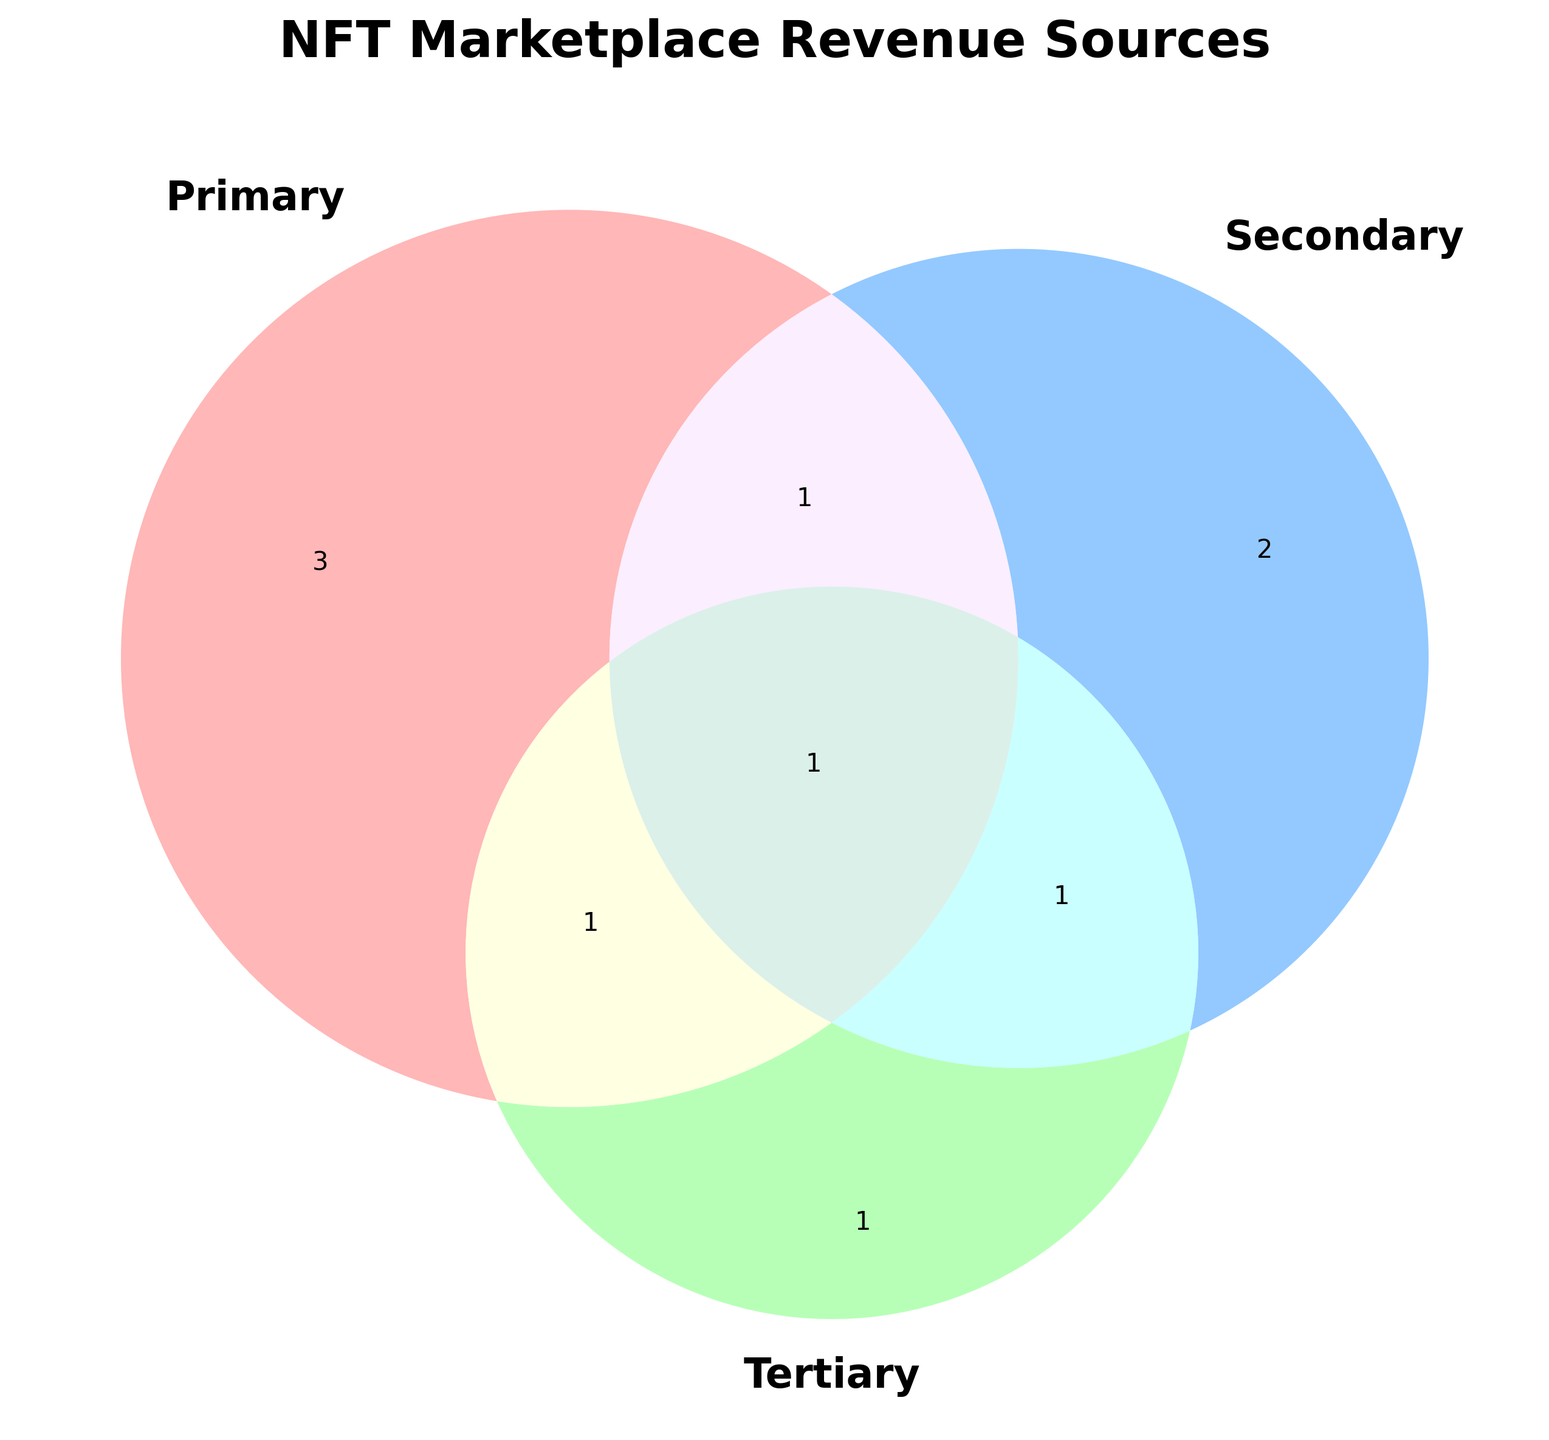Which sets do "Cryptocurrency Exchange" belong to? "Cryptocurrency Exchange" is at the center overlapping all three sets, so it belongs to Primary, Secondary, and Tertiary categories.
Answer: All three (Primary, Secondary, Tertiary) What are the revenue sources unique to the "Primary" set? The unique sources for the "Primary" set are the ones that only appear in the segment of the Venn diagram labeled as "Primary".
Answer: Transaction Fees, Listing Fees, Creator Royalties How many revenue sources intersect between "Primary" and "Secondary" sets? Identify the section on the Venn diagram where "Primary" and "Secondary" sets overlap, excluding the tertiary set.
Answer: One (Premium Features) Which category does "Exclusive Drops" fall under? “Exclusive Drops” is within the overlapping section of "Primary" and "Tertiary" sets.
Answer: Primary and Tertiary What is the total number of unique revenue sources in the secondary set? Count the items in the Secondary circle, including overlaps with other sets, but not counting repeated sources.
Answer: Four (Subscription Plans, Advertising, Premium Features, NFT Analytics) Which revenue sources overlap between "Secondary" and "Tertiary"? Locate the overlapping section between "Secondary" and "Tertiary" in the Venn diagram.
Answer: NFT Analytics What are the revenue sources in the intersection of all three categories? Locate the center part of the Venn diagram where all three sets overlap.
Answer: Cryptocurrency Exchange What is the set relationship between "Premium Features" and the categories? "Premium Features" is located in the overlapping area between "Primary" and "Secondary" which means it belongs to both categories.
Answer: Primary and Secondary How many revenue sources belong exclusively to the "Tertiary" category? Count the items that appear only in the section of the Venn diagram labeled "Tertiary".
Answer: One (Virtual Gallery Rentals) Which category contains "Advertising"? "Advertising" is located within the section labeled "Secondary" only.
Answer: Secondary 